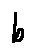Convert formula to latex. <formula><loc_0><loc_0><loc_500><loc_500>b</formula> 